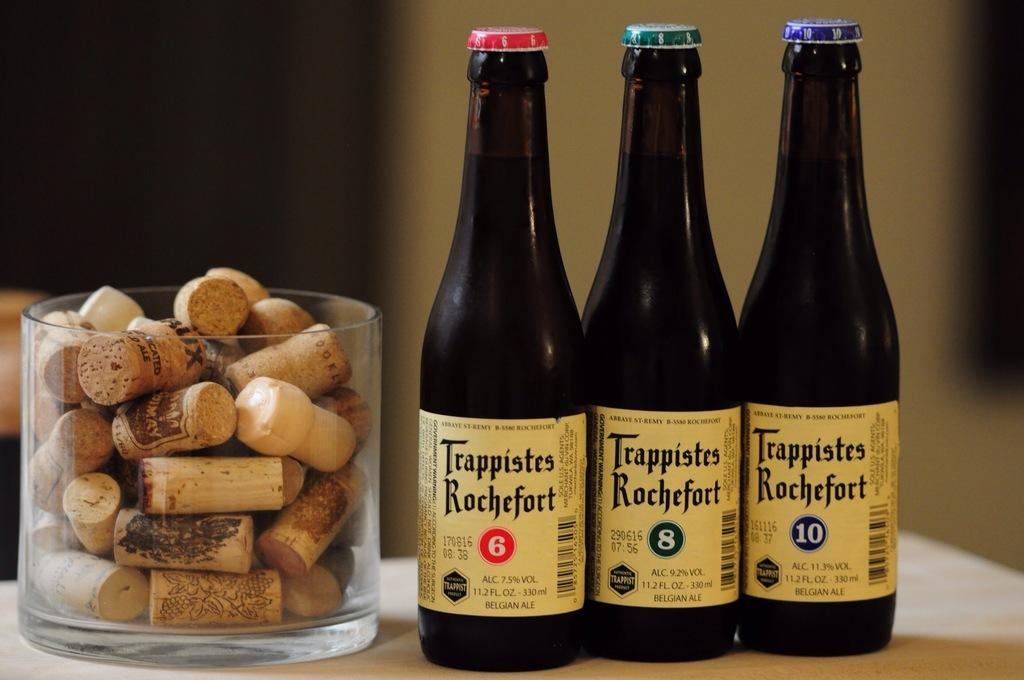<image>
Share a concise interpretation of the image provided. The bottles include the numbers 6, 8 and 10. 